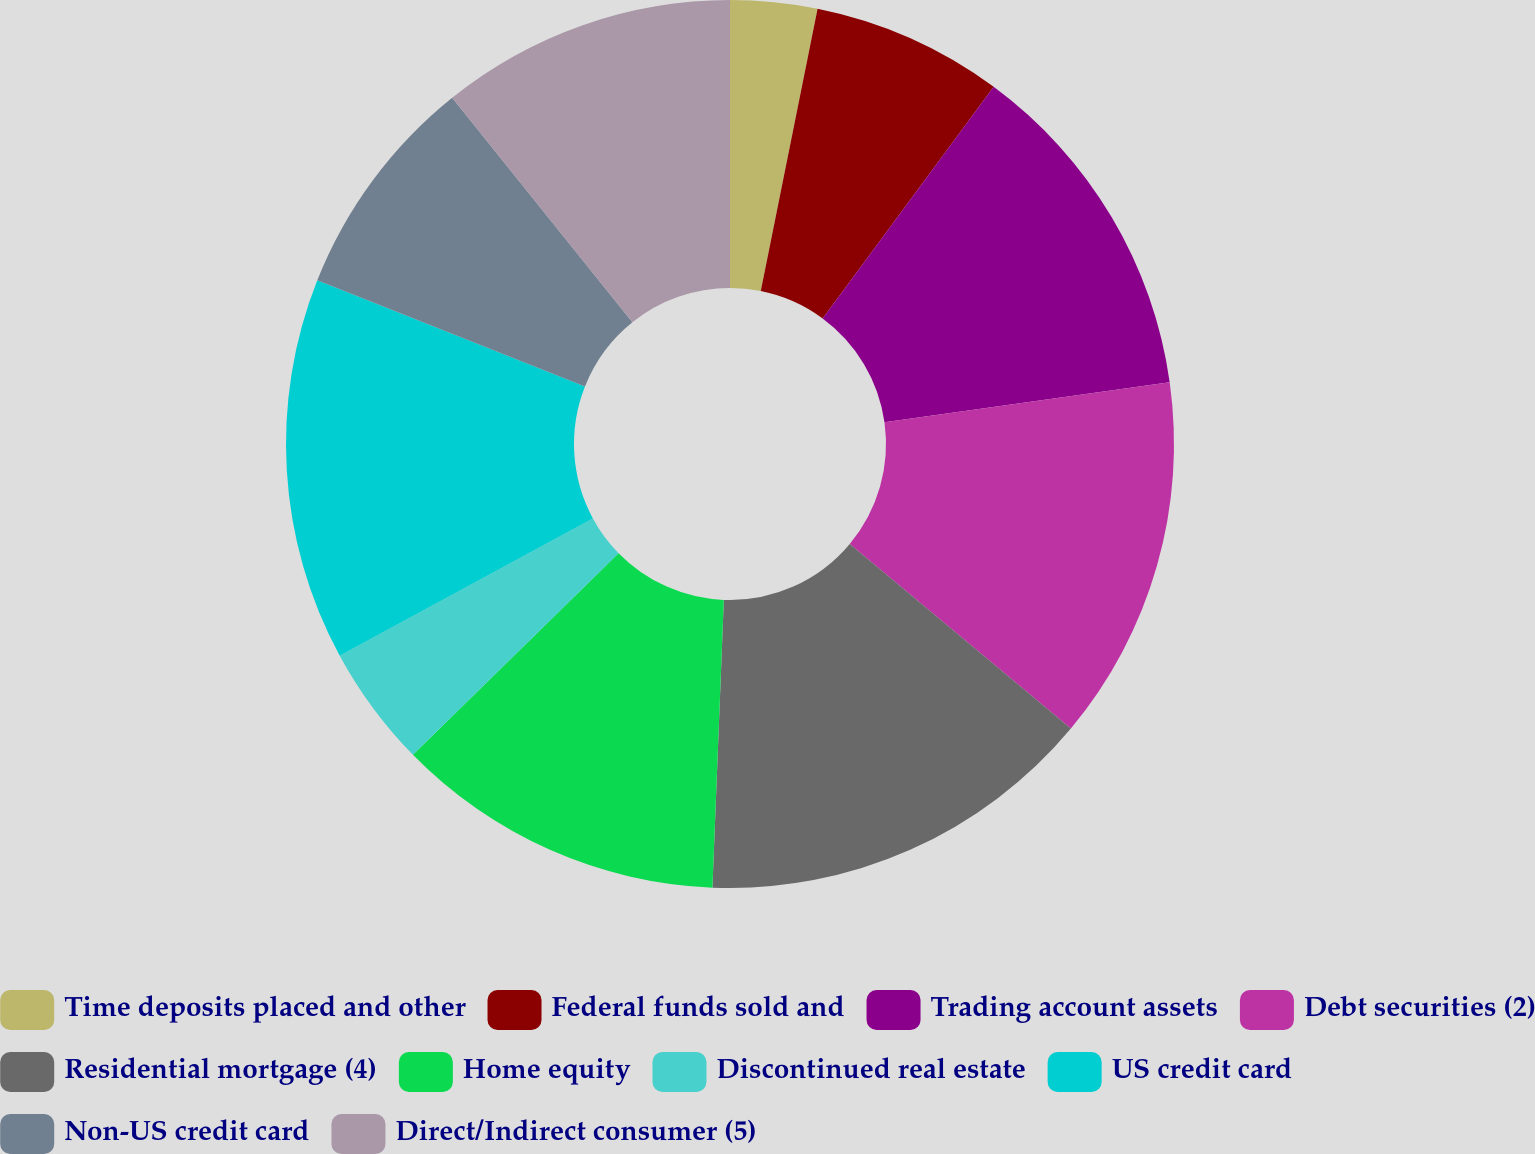Convert chart. <chart><loc_0><loc_0><loc_500><loc_500><pie_chart><fcel>Time deposits placed and other<fcel>Federal funds sold and<fcel>Trading account assets<fcel>Debt securities (2)<fcel>Residential mortgage (4)<fcel>Home equity<fcel>Discontinued real estate<fcel>US credit card<fcel>Non-US credit card<fcel>Direct/Indirect consumer (5)<nl><fcel>3.16%<fcel>6.96%<fcel>12.66%<fcel>13.29%<fcel>14.56%<fcel>12.03%<fcel>4.43%<fcel>13.92%<fcel>8.23%<fcel>10.76%<nl></chart> 